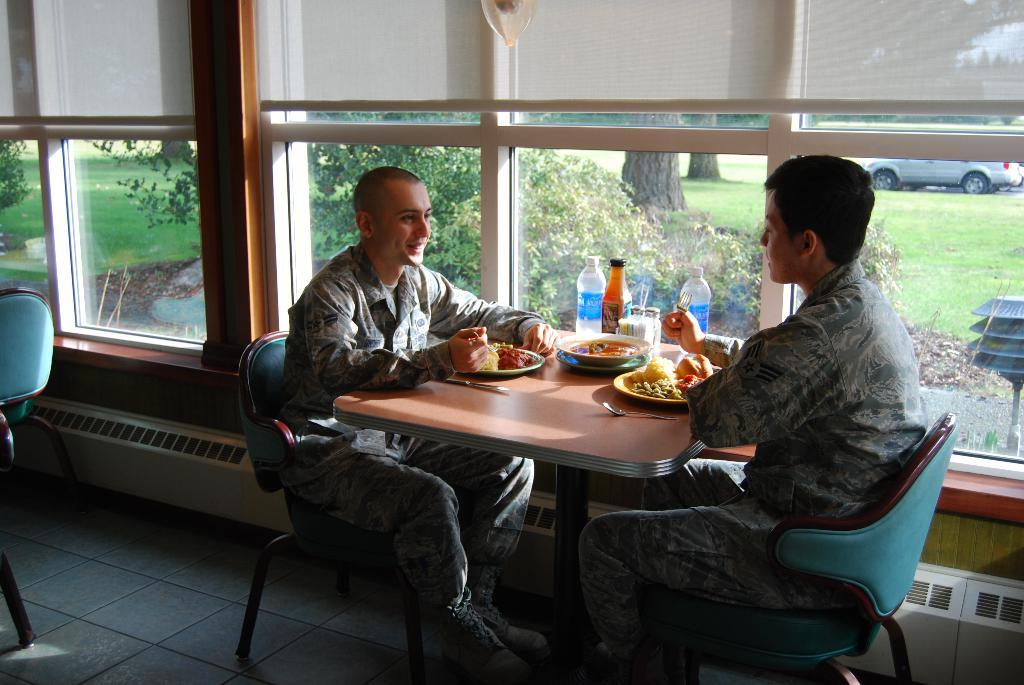How many people are in the image? There are two men in the image. What are the men doing in the image? The men are seated on chairs. What is on the table in the image? There is a table in the image, and food and water bottles are visible on the table. What type of question is being asked by the sponge in the image? There is no sponge present in the image, and therefore no questions are being asked by a sponge. 